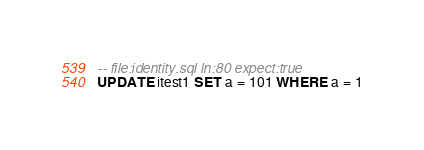Convert code to text. <code><loc_0><loc_0><loc_500><loc_500><_SQL_>-- file:identity.sql ln:80 expect:true
UPDATE itest1 SET a = 101 WHERE a = 1
</code> 